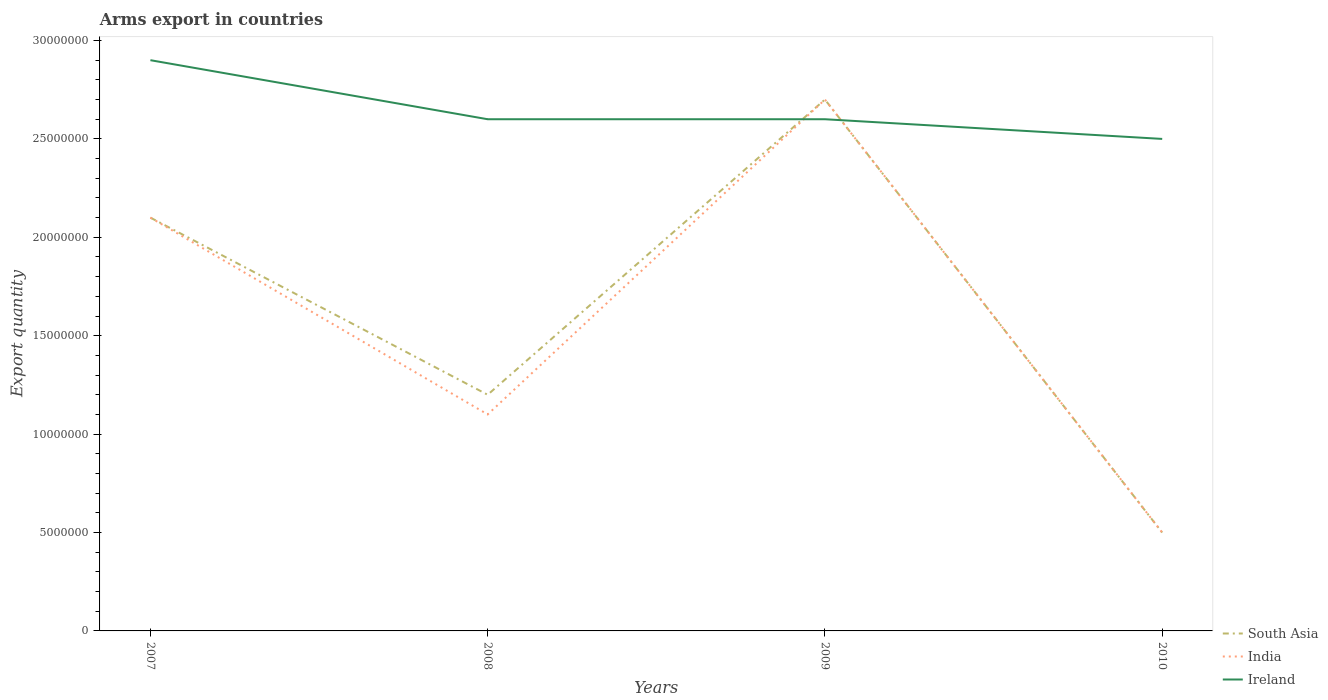Does the line corresponding to South Asia intersect with the line corresponding to Ireland?
Offer a terse response. Yes. What is the total total arms export in South Asia in the graph?
Make the answer very short. -1.50e+07. What is the difference between the highest and the second highest total arms export in India?
Provide a short and direct response. 2.20e+07. What is the difference between the highest and the lowest total arms export in Ireland?
Your answer should be compact. 1. Is the total arms export in Ireland strictly greater than the total arms export in South Asia over the years?
Offer a terse response. No. What is the difference between two consecutive major ticks on the Y-axis?
Your answer should be compact. 5.00e+06. Does the graph contain any zero values?
Provide a succinct answer. No. Where does the legend appear in the graph?
Your response must be concise. Bottom right. How many legend labels are there?
Offer a very short reply. 3. What is the title of the graph?
Offer a very short reply. Arms export in countries. Does "Lithuania" appear as one of the legend labels in the graph?
Your response must be concise. No. What is the label or title of the X-axis?
Your answer should be very brief. Years. What is the label or title of the Y-axis?
Your answer should be very brief. Export quantity. What is the Export quantity of South Asia in 2007?
Give a very brief answer. 2.10e+07. What is the Export quantity in India in 2007?
Give a very brief answer. 2.10e+07. What is the Export quantity of Ireland in 2007?
Make the answer very short. 2.90e+07. What is the Export quantity in India in 2008?
Provide a succinct answer. 1.10e+07. What is the Export quantity in Ireland in 2008?
Your answer should be very brief. 2.60e+07. What is the Export quantity of South Asia in 2009?
Your response must be concise. 2.70e+07. What is the Export quantity in India in 2009?
Your response must be concise. 2.70e+07. What is the Export quantity in Ireland in 2009?
Offer a very short reply. 2.60e+07. What is the Export quantity of Ireland in 2010?
Give a very brief answer. 2.50e+07. Across all years, what is the maximum Export quantity in South Asia?
Offer a very short reply. 2.70e+07. Across all years, what is the maximum Export quantity in India?
Give a very brief answer. 2.70e+07. Across all years, what is the maximum Export quantity in Ireland?
Keep it short and to the point. 2.90e+07. Across all years, what is the minimum Export quantity of South Asia?
Your answer should be very brief. 5.00e+06. Across all years, what is the minimum Export quantity in India?
Your response must be concise. 5.00e+06. Across all years, what is the minimum Export quantity of Ireland?
Your answer should be very brief. 2.50e+07. What is the total Export quantity of South Asia in the graph?
Your answer should be compact. 6.50e+07. What is the total Export quantity in India in the graph?
Provide a succinct answer. 6.40e+07. What is the total Export quantity in Ireland in the graph?
Your answer should be compact. 1.06e+08. What is the difference between the Export quantity of South Asia in 2007 and that in 2008?
Keep it short and to the point. 9.00e+06. What is the difference between the Export quantity in Ireland in 2007 and that in 2008?
Provide a succinct answer. 3.00e+06. What is the difference between the Export quantity of South Asia in 2007 and that in 2009?
Your response must be concise. -6.00e+06. What is the difference between the Export quantity of India in 2007 and that in 2009?
Your answer should be compact. -6.00e+06. What is the difference between the Export quantity of South Asia in 2007 and that in 2010?
Ensure brevity in your answer.  1.60e+07. What is the difference between the Export quantity of India in 2007 and that in 2010?
Ensure brevity in your answer.  1.60e+07. What is the difference between the Export quantity in South Asia in 2008 and that in 2009?
Provide a short and direct response. -1.50e+07. What is the difference between the Export quantity of India in 2008 and that in 2009?
Your answer should be very brief. -1.60e+07. What is the difference between the Export quantity in Ireland in 2008 and that in 2009?
Offer a very short reply. 0. What is the difference between the Export quantity of India in 2008 and that in 2010?
Ensure brevity in your answer.  6.00e+06. What is the difference between the Export quantity of South Asia in 2009 and that in 2010?
Keep it short and to the point. 2.20e+07. What is the difference between the Export quantity in India in 2009 and that in 2010?
Offer a terse response. 2.20e+07. What is the difference between the Export quantity of South Asia in 2007 and the Export quantity of India in 2008?
Give a very brief answer. 1.00e+07. What is the difference between the Export quantity in South Asia in 2007 and the Export quantity in Ireland in 2008?
Make the answer very short. -5.00e+06. What is the difference between the Export quantity in India in 2007 and the Export quantity in Ireland in 2008?
Ensure brevity in your answer.  -5.00e+06. What is the difference between the Export quantity in South Asia in 2007 and the Export quantity in India in 2009?
Your answer should be very brief. -6.00e+06. What is the difference between the Export quantity in South Asia in 2007 and the Export quantity in Ireland in 2009?
Your response must be concise. -5.00e+06. What is the difference between the Export quantity in India in 2007 and the Export quantity in Ireland in 2009?
Offer a very short reply. -5.00e+06. What is the difference between the Export quantity in South Asia in 2007 and the Export quantity in India in 2010?
Provide a succinct answer. 1.60e+07. What is the difference between the Export quantity in South Asia in 2007 and the Export quantity in Ireland in 2010?
Ensure brevity in your answer.  -4.00e+06. What is the difference between the Export quantity of South Asia in 2008 and the Export quantity of India in 2009?
Your response must be concise. -1.50e+07. What is the difference between the Export quantity in South Asia in 2008 and the Export quantity in Ireland in 2009?
Your answer should be very brief. -1.40e+07. What is the difference between the Export quantity of India in 2008 and the Export quantity of Ireland in 2009?
Your answer should be compact. -1.50e+07. What is the difference between the Export quantity of South Asia in 2008 and the Export quantity of Ireland in 2010?
Your answer should be very brief. -1.30e+07. What is the difference between the Export quantity of India in 2008 and the Export quantity of Ireland in 2010?
Give a very brief answer. -1.40e+07. What is the difference between the Export quantity in South Asia in 2009 and the Export quantity in India in 2010?
Provide a succinct answer. 2.20e+07. What is the difference between the Export quantity of South Asia in 2009 and the Export quantity of Ireland in 2010?
Provide a succinct answer. 2.00e+06. What is the difference between the Export quantity of India in 2009 and the Export quantity of Ireland in 2010?
Provide a succinct answer. 2.00e+06. What is the average Export quantity of South Asia per year?
Your answer should be compact. 1.62e+07. What is the average Export quantity in India per year?
Make the answer very short. 1.60e+07. What is the average Export quantity in Ireland per year?
Your answer should be compact. 2.65e+07. In the year 2007, what is the difference between the Export quantity in South Asia and Export quantity in Ireland?
Keep it short and to the point. -8.00e+06. In the year 2007, what is the difference between the Export quantity of India and Export quantity of Ireland?
Offer a very short reply. -8.00e+06. In the year 2008, what is the difference between the Export quantity in South Asia and Export quantity in Ireland?
Ensure brevity in your answer.  -1.40e+07. In the year 2008, what is the difference between the Export quantity of India and Export quantity of Ireland?
Provide a succinct answer. -1.50e+07. In the year 2009, what is the difference between the Export quantity in South Asia and Export quantity in Ireland?
Provide a short and direct response. 1.00e+06. In the year 2010, what is the difference between the Export quantity in South Asia and Export quantity in India?
Make the answer very short. 0. In the year 2010, what is the difference between the Export quantity of South Asia and Export quantity of Ireland?
Give a very brief answer. -2.00e+07. In the year 2010, what is the difference between the Export quantity in India and Export quantity in Ireland?
Provide a short and direct response. -2.00e+07. What is the ratio of the Export quantity in India in 2007 to that in 2008?
Ensure brevity in your answer.  1.91. What is the ratio of the Export quantity of Ireland in 2007 to that in 2008?
Make the answer very short. 1.12. What is the ratio of the Export quantity in India in 2007 to that in 2009?
Keep it short and to the point. 0.78. What is the ratio of the Export quantity of Ireland in 2007 to that in 2009?
Your answer should be very brief. 1.12. What is the ratio of the Export quantity in Ireland in 2007 to that in 2010?
Your response must be concise. 1.16. What is the ratio of the Export quantity of South Asia in 2008 to that in 2009?
Make the answer very short. 0.44. What is the ratio of the Export quantity in India in 2008 to that in 2009?
Your response must be concise. 0.41. What is the ratio of the Export quantity of Ireland in 2008 to that in 2010?
Provide a short and direct response. 1.04. What is the ratio of the Export quantity of South Asia in 2009 to that in 2010?
Offer a very short reply. 5.4. What is the ratio of the Export quantity of India in 2009 to that in 2010?
Provide a short and direct response. 5.4. What is the difference between the highest and the second highest Export quantity of South Asia?
Provide a succinct answer. 6.00e+06. What is the difference between the highest and the second highest Export quantity in India?
Offer a terse response. 6.00e+06. What is the difference between the highest and the second highest Export quantity of Ireland?
Provide a succinct answer. 3.00e+06. What is the difference between the highest and the lowest Export quantity in South Asia?
Ensure brevity in your answer.  2.20e+07. What is the difference between the highest and the lowest Export quantity of India?
Your answer should be very brief. 2.20e+07. 